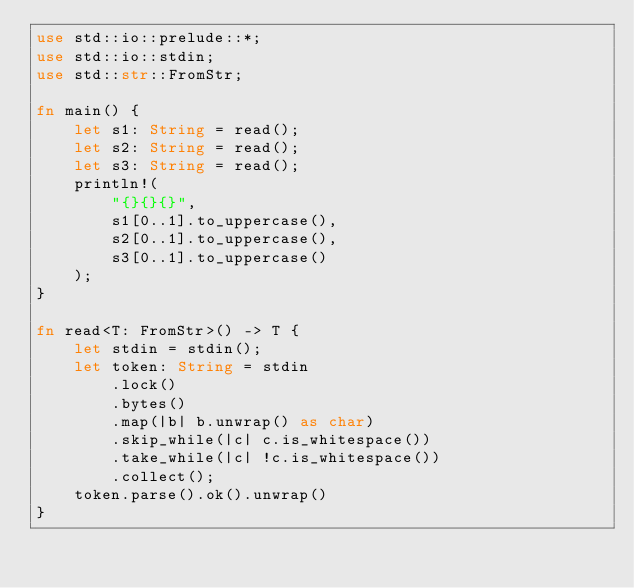<code> <loc_0><loc_0><loc_500><loc_500><_Rust_>use std::io::prelude::*;
use std::io::stdin;
use std::str::FromStr;

fn main() {
    let s1: String = read();
    let s2: String = read();
    let s3: String = read();
    println!(
        "{}{}{}",
        s1[0..1].to_uppercase(),
        s2[0..1].to_uppercase(),
        s3[0..1].to_uppercase()
    );
}

fn read<T: FromStr>() -> T {
    let stdin = stdin();
    let token: String = stdin
        .lock()
        .bytes()
        .map(|b| b.unwrap() as char)
        .skip_while(|c| c.is_whitespace())
        .take_while(|c| !c.is_whitespace())
        .collect();
    token.parse().ok().unwrap()
}
</code> 